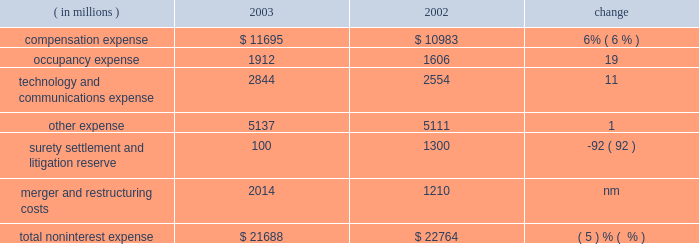Management 2019s discussion and analysis j.p .
Morgan chase & co .
26 j.p .
Morgan chase & co .
/ 2003 annual report $ 41.7 billion .
Nii was reduced by a lower volume of commercial loans and lower spreads on investment securities .
As a compo- nent of nii , trading-related net interest income of $ 2.1 billion was up 13% ( 13 % ) from 2002 due to a change in the composition of , and growth in , trading assets .
The firm 2019s total average interest-earning assets in 2003 were $ 590 billion , up 6% ( 6 % ) from the prior year .
The net interest yield on these assets , on a fully taxable-equivalent basis , was 2.10% ( 2.10 % ) , compared with 2.09% ( 2.09 % ) in the prior year .
Noninterest expense year ended december 31 .
Technology and communications expense in 2003 , technology and communications expense was 11% ( 11 % ) above the prior-year level .
The increase was primarily due to a shift in expenses : costs that were previously associated with compensation and other expenses shifted , upon the commence- ment of the ibm outsourcing agreement , to technology and communications expense .
Also contributing to the increase were higher costs related to software amortization .
For a further dis- cussion of the ibm outsourcing agreement , see support units and corporate on page 44 of this annual report .
Other expense other expense in 2003 rose slightly from the prior year , reflecting higher outside services .
For a table showing the components of other expense , see note 8 on page 96 of this annual report .
Surety settlement and litigation reserve the firm added $ 100 million to the enron-related litigation reserve in 2003 to supplement a $ 900 million reserve initially recorded in 2002 .
The 2002 reserve was established to cover enron-related matters , as well as certain other material litigation , proceedings and investigations in which the firm is involved .
In addition , in 2002 the firm recorded a charge of $ 400 million for the settlement of enron-related surety litigation .
Merger and restructuring costs merger and restructuring costs related to business restructurings announced after january 1 , 2002 , were recorded in their relevant expense categories .
In 2002 , merger and restructuring costs of $ 1.2 billion , for programs announced prior to january 1 , 2002 , were viewed by management as nonoperating expenses or 201cspecial items . 201d refer to note 8 on pages 95 201396 of this annual report for a further discussion of merger and restructuring costs and for a summary , by expense category and business segment , of costs incurred in 2003 and 2002 for programs announced after january 1 , 2002 .
Provision for credit losses the 2003 provision for credit losses was $ 2.8 billion lower than in 2002 , primarily reflecting continued improvement in the quality of the commercial loan portfolio and a higher volume of credit card securitizations .
For further information about the provision for credit losses and the firm 2019s management of credit risk , see the dis- cussions of net charge-offs associated with the commercial and consumer loan portfolios and the allowance for credit losses , on pages 63 201365 of this annual report .
Income tax expense income tax expense was $ 3.3 billion in 2003 , compared with $ 856 million in 2002 .
The effective tax rate in 2003 was 33% ( 33 % ) , compared with 34% ( 34 % ) in 2002 .
The tax rate decline was principally attributable to changes in the proportion of income subject to state and local taxes .
Compensation expense compensation expense in 2003 was 6% ( 6 % ) higher than in the prior year .
The increase principally reflected higher performance-related incentives , and higher pension and other postretirement benefit costs , primarily as a result of changes in actuarial assumptions .
For a detailed discussion of pension and other postretirement benefit costs , see note 6 on pages 89 201393 of this annual report .
The increase pertaining to incentives included $ 266 million as a result of adopting sfas 123 , and $ 120 million from the reversal in 2002 of previously accrued expenses for certain forfeitable key employ- ee stock awards , as discussed in note 7 on pages 93 201395 of this annual report .
Total compensation expense declined as a result of the transfer , beginning april 1 , 2003 , of 2800 employees to ibm in connection with a technology outsourcing agreement .
The total number of full-time equivalent employees at december 31 , 2003 was 93453 compared with 94335 at the prior year-end .
Occupancy expense occupancy expense of $ 1.9 billion rose 19% ( 19 % ) from 2002 .
The increase reflected costs of additional leased space in midtown manhattan and in the south and southwest regions of the united states ; higher real estate taxes in new york city ; and the cost of enhanced safety measures .
Also contributing to the increase were charges for unoccupied excess real estate of $ 270 million ; this compared with $ 120 million in 2002 , mostly in the third quarter of that year. .
In 2003 what was the percent of the total noninterest expense that was related to compensation? 
Computations: (11695 / 21688)
Answer: 0.53924. 